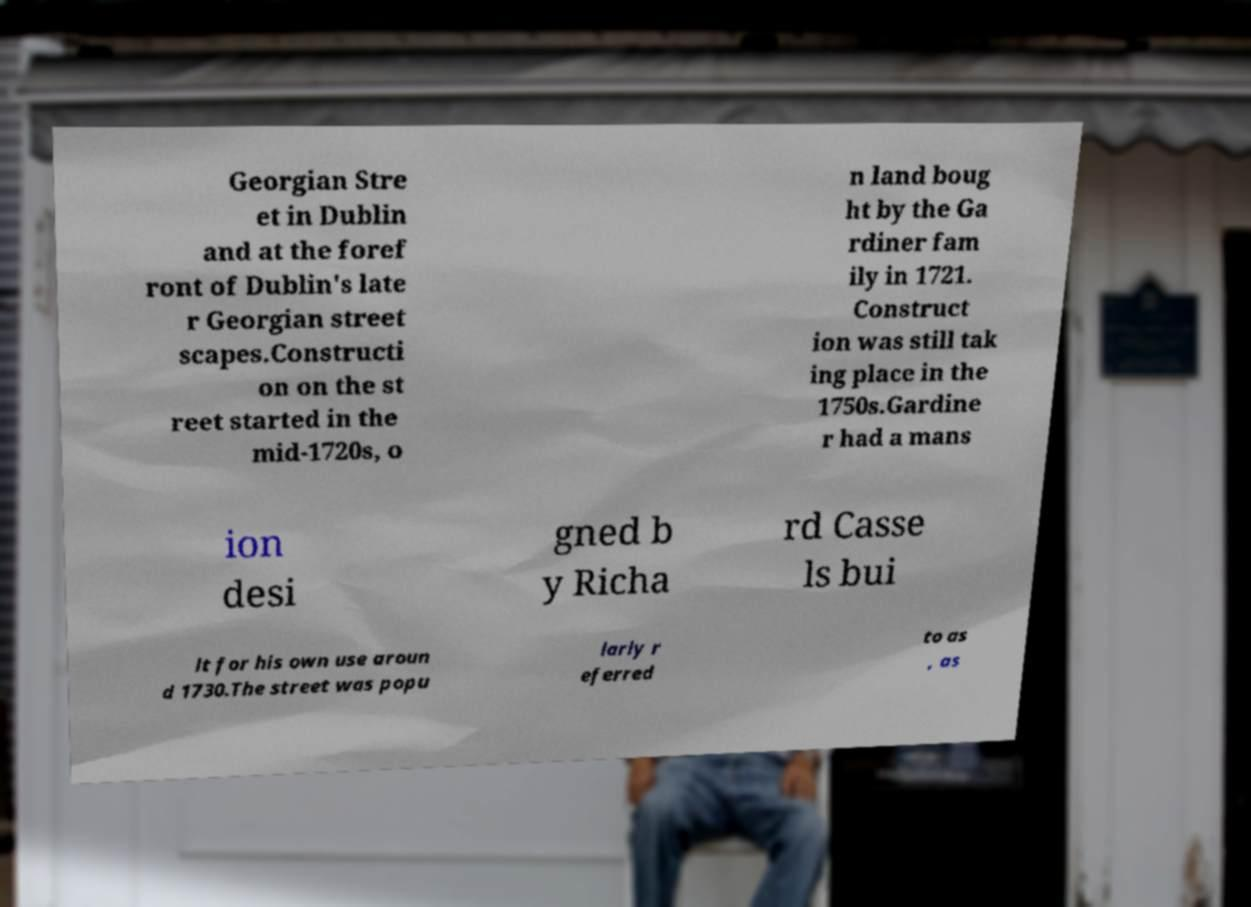What messages or text are displayed in this image? I need them in a readable, typed format. Georgian Stre et in Dublin and at the foref ront of Dublin's late r Georgian street scapes.Constructi on on the st reet started in the mid-1720s, o n land boug ht by the Ga rdiner fam ily in 1721. Construct ion was still tak ing place in the 1750s.Gardine r had a mans ion desi gned b y Richa rd Casse ls bui lt for his own use aroun d 1730.The street was popu larly r eferred to as , as 